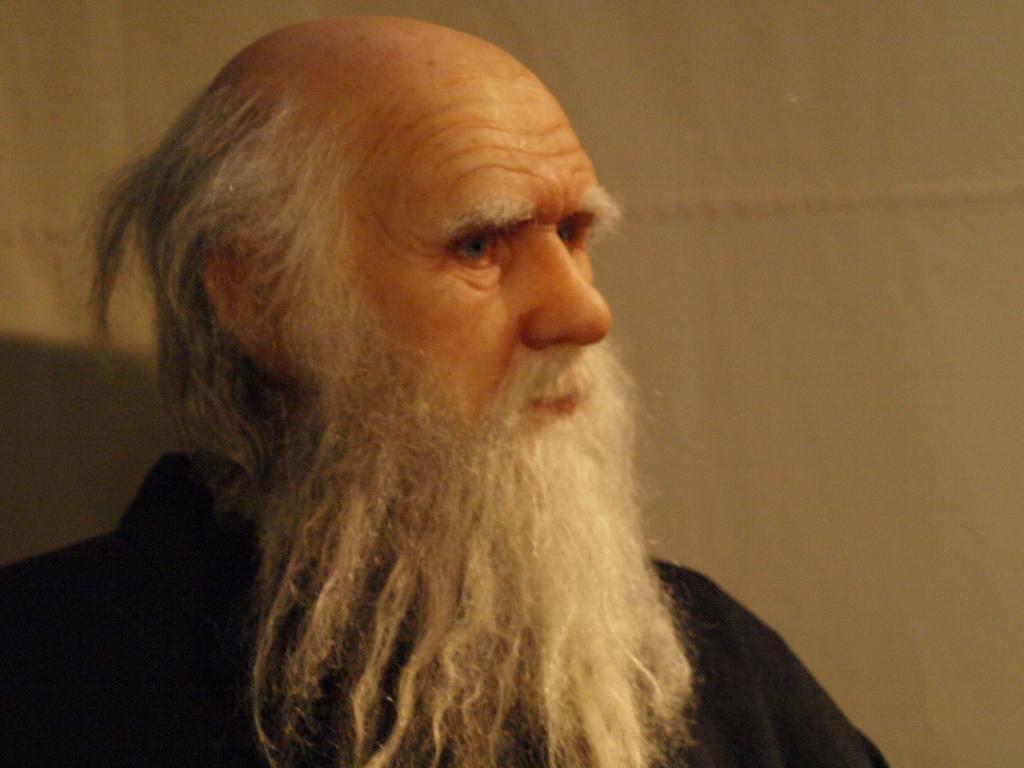Please provide a concise description of this image. In this picture there is an old man in the center of the image, with a white beard. 